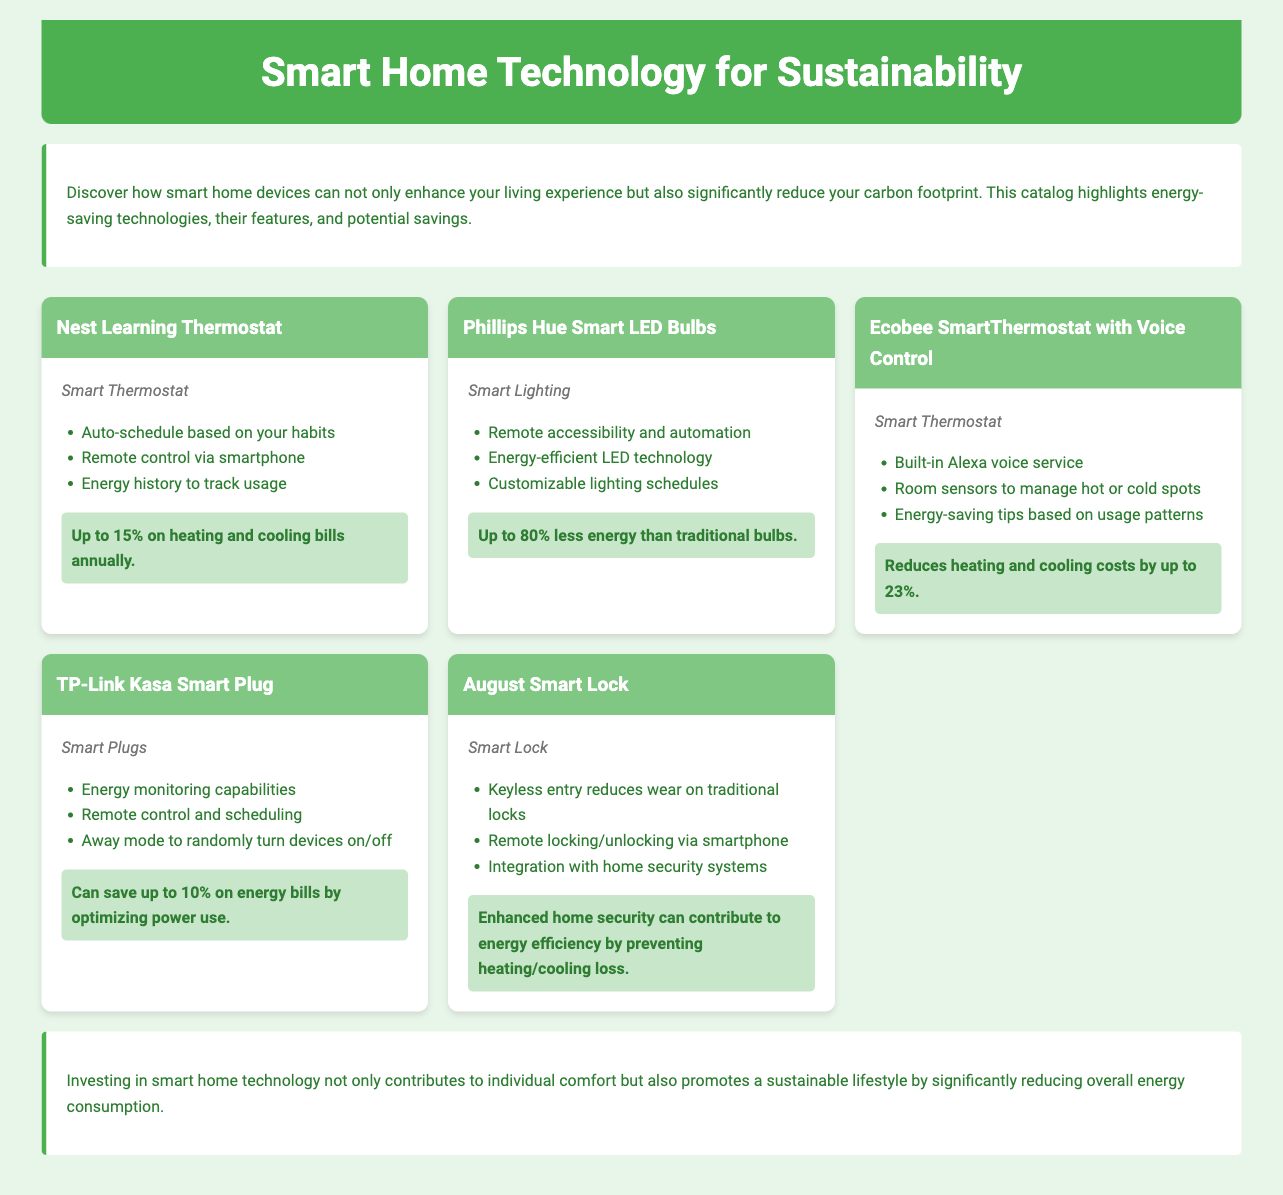what is the name of the first device listed? The name of the first device listed in the catalog is "Nest Learning Thermostat."
Answer: Nest Learning Thermostat what percentage can the Ecobee SmartThermostat reduce heating and cooling costs? The document states that the Ecobee SmartThermostat can reduce heating and cooling costs by up to 23%.
Answer: 23% which device uses energy-efficient LED technology? The device that uses energy-efficient LED technology is "Phillips Hue Smart LED Bulbs."
Answer: Phillips Hue Smart LED Bulbs how much can the TP-Link Kasa Smart Plug save on energy bills? The TP-Link Kasa Smart Plug can save up to 10% on energy bills by optimizing power use.
Answer: 10% what feature allows remote control of the August Smart Lock? The August Smart Lock allows remote locking/unlocking via smartphone, which is its key feature.
Answer: remote locking/unlocking via smartphone what is the main benefit of using smart plugs mentioned in the document? The main benefit mentioned is energy monitoring capabilities and scheduling to optimize power use.
Answer: energy monitoring capabilities what type of technology does the catalog focus on? The catalog focuses on smart home technology and its role in sustainability.
Answer: smart home technology what is the savings percentage for Phillips Hue Smart LED Bulbs compared to traditional bulbs? The savings percentage for Phillips Hue Smart LED Bulbs compared to traditional bulbs is up to 80%.
Answer: 80% 